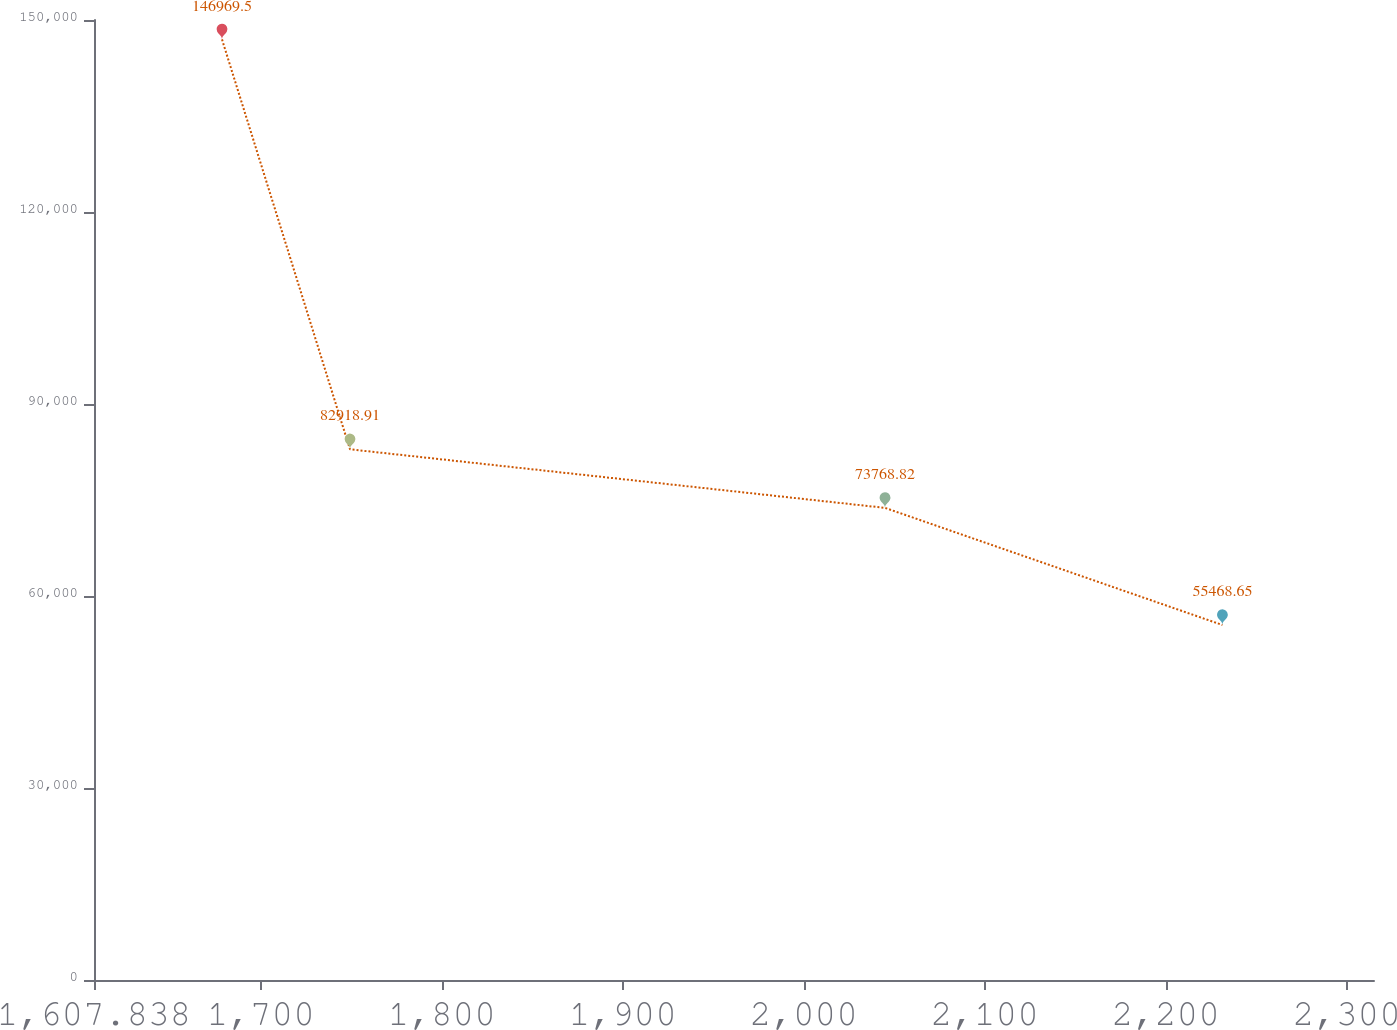<chart> <loc_0><loc_0><loc_500><loc_500><line_chart><ecel><fcel>Unnamed: 1<nl><fcel>1678.56<fcel>146970<nl><fcel>1749.28<fcel>82918.9<nl><fcel>2044.88<fcel>73768.8<nl><fcel>2231.3<fcel>55468.7<nl><fcel>2385.78<fcel>64618.7<nl></chart> 